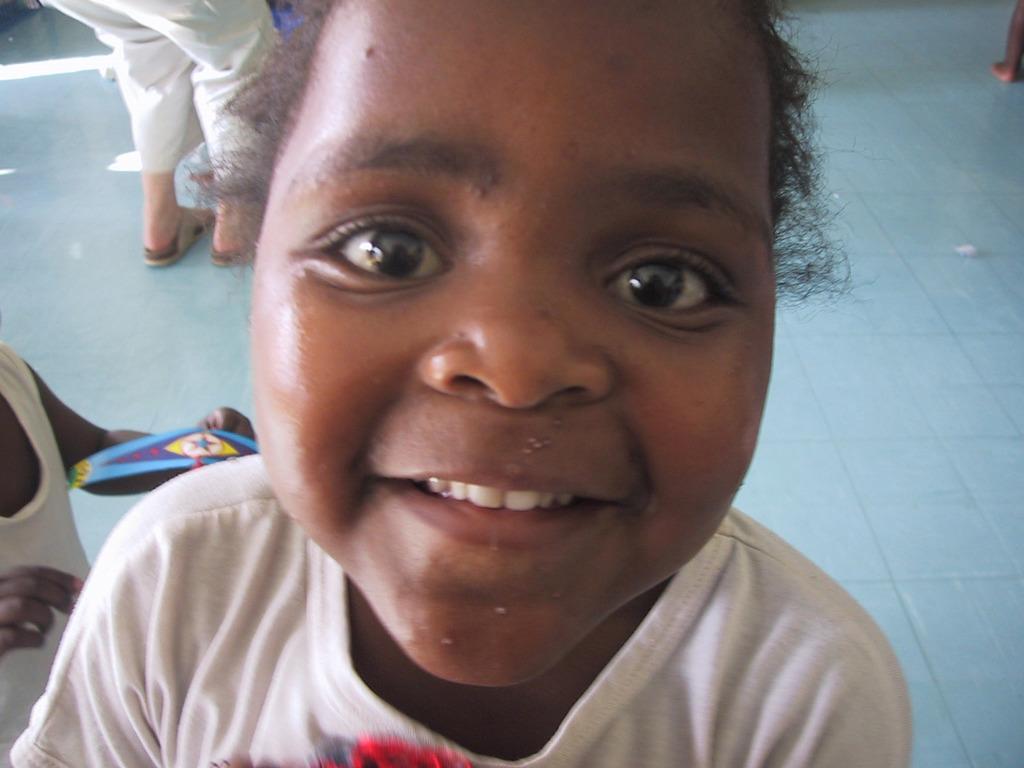Could you give a brief overview of what you see in this image? In this image we can see the kid smiling. In the background we can see the people and also the floor. On the left we can see a person holding an object. 